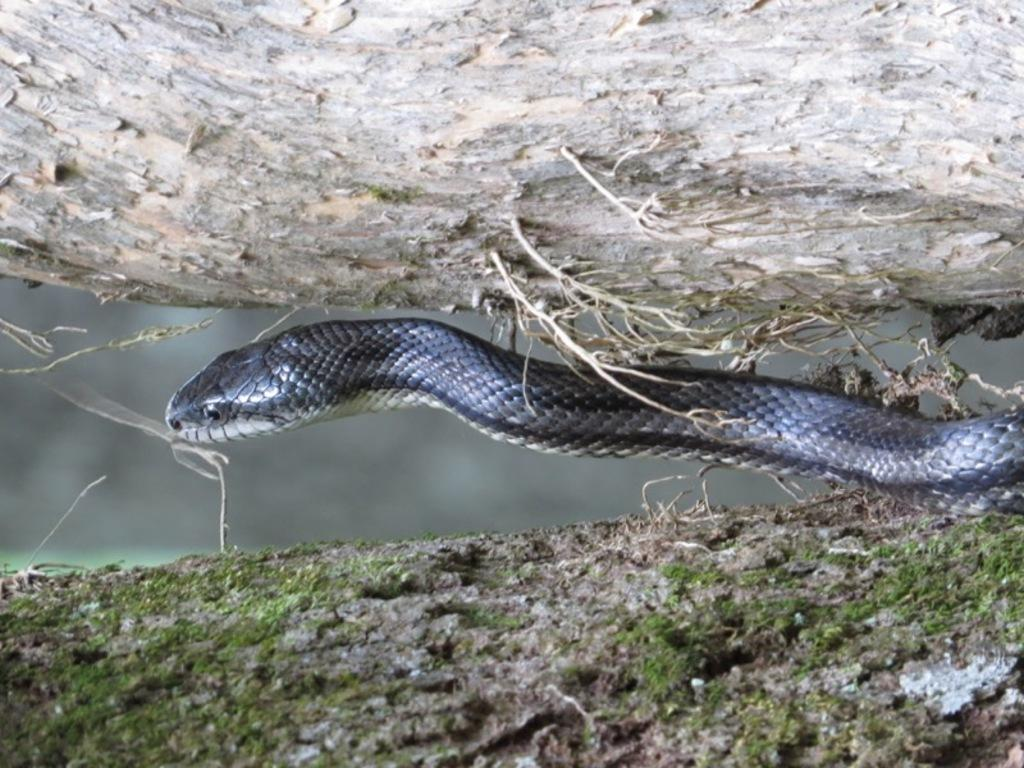What animal is present in the image? There is a snake in the image. Where is the snake located in relation to the tree trunks? The snake is between tree trunks. Can you describe the background of the image? The background of the image is blurred. What type of cow can be seen grazing in the background of the image? There is no cow present in the image; it features a snake between tree trunks. What household item is being used to clean the snake in the image? There is no sponge or any cleaning activity depicted in the image; it shows a snake between tree trunks with a blurred background. 